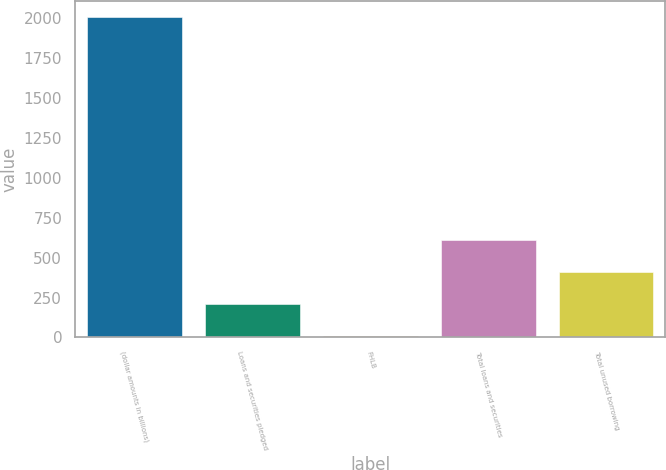<chart> <loc_0><loc_0><loc_500><loc_500><bar_chart><fcel>(dollar amounts in billions)<fcel>Loans and securities pledged<fcel>FHLB<fcel>Total loans and securities<fcel>Total unused borrowing<nl><fcel>2011<fcel>208.48<fcel>8.2<fcel>609.04<fcel>408.76<nl></chart> 